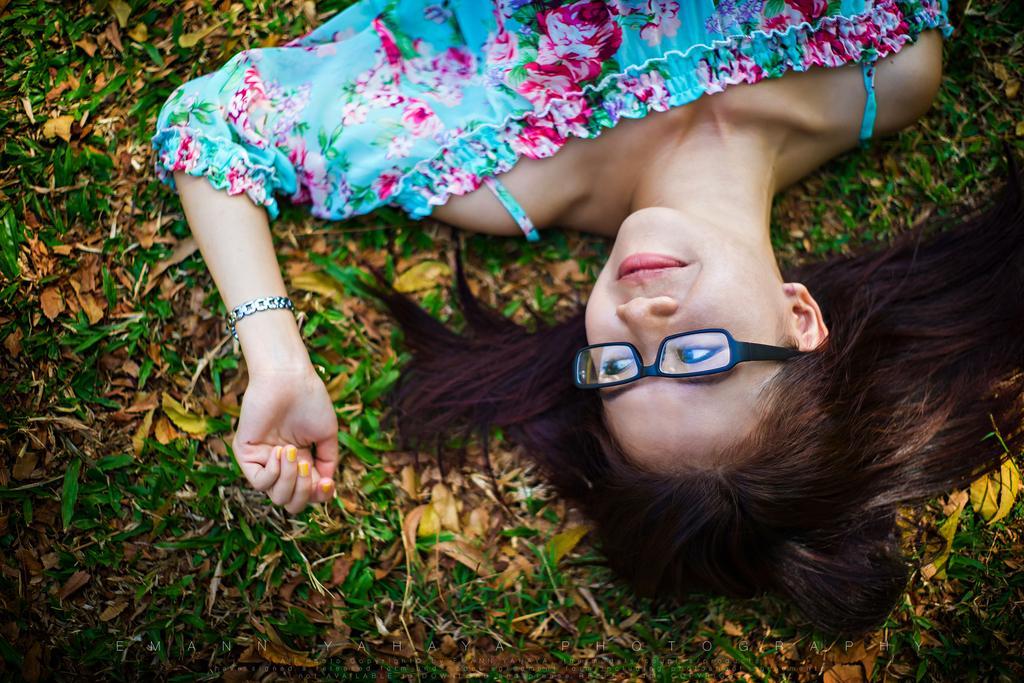Could you give a brief overview of what you see in this image? In this image there is a person smiling and lying on the leaves, and there is a watermark on the image. 